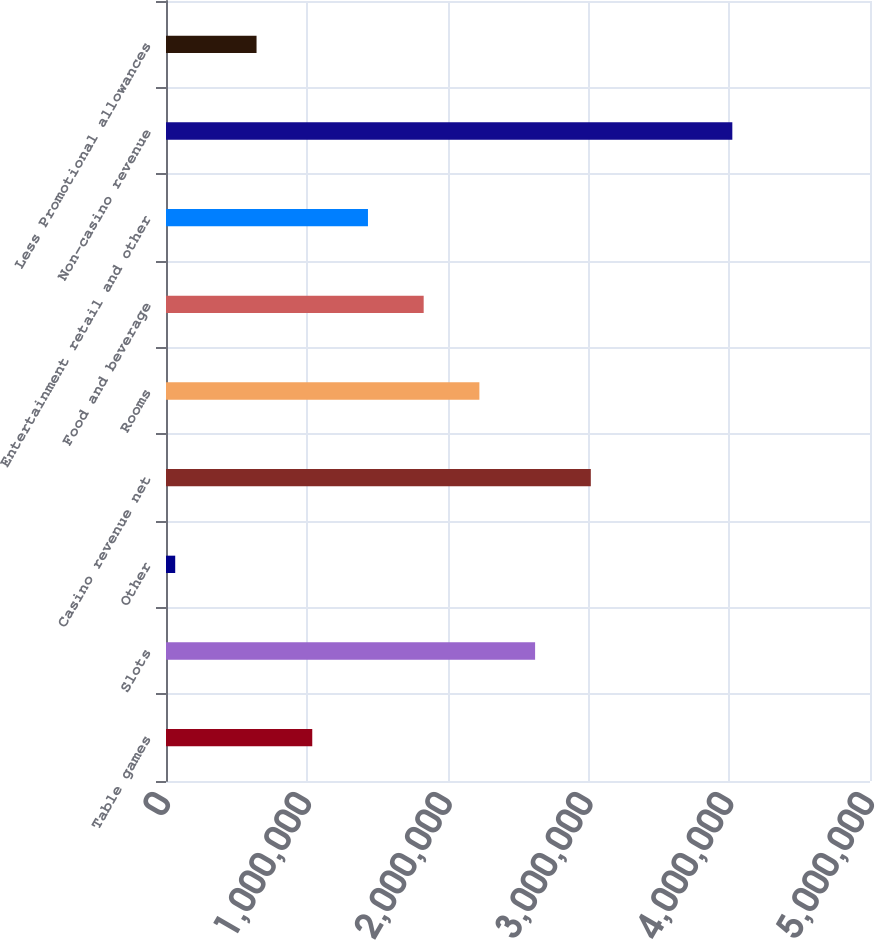Convert chart to OTSL. <chart><loc_0><loc_0><loc_500><loc_500><bar_chart><fcel>Table games<fcel>Slots<fcel>Other<fcel>Casino revenue net<fcel>Rooms<fcel>Food and beverage<fcel>Entertainment retail and other<fcel>Non-casino revenue<fcel>Less Promotional allowances<nl><fcel>1.03874e+06<fcel>2.62144e+06<fcel>65450<fcel>3.01711e+06<fcel>2.22576e+06<fcel>1.83009e+06<fcel>1.43442e+06<fcel>4.02219e+06<fcel>643068<nl></chart> 